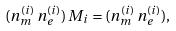<formula> <loc_0><loc_0><loc_500><loc_500>( n _ { m } ^ { ( i ) } \, n _ { e } ^ { ( i ) } ) \, M _ { i } = ( n _ { m } ^ { ( i ) } \, n _ { e } ^ { ( i ) } ) ,</formula> 